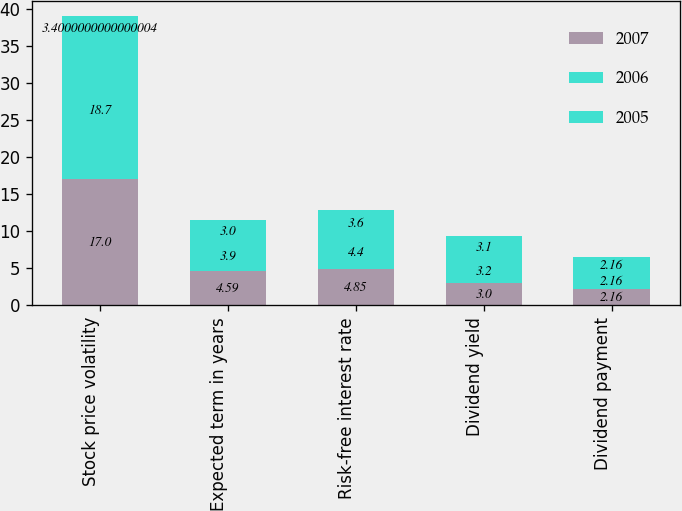Convert chart to OTSL. <chart><loc_0><loc_0><loc_500><loc_500><stacked_bar_chart><ecel><fcel>Stock price volatility<fcel>Expected term in years<fcel>Risk-free interest rate<fcel>Dividend yield<fcel>Dividend payment<nl><fcel>2007<fcel>17<fcel>4.59<fcel>4.85<fcel>3<fcel>2.16<nl><fcel>2006<fcel>18.7<fcel>3.9<fcel>4.4<fcel>3.2<fcel>2.16<nl><fcel>2005<fcel>3.4<fcel>3<fcel>3.6<fcel>3.1<fcel>2.16<nl></chart> 